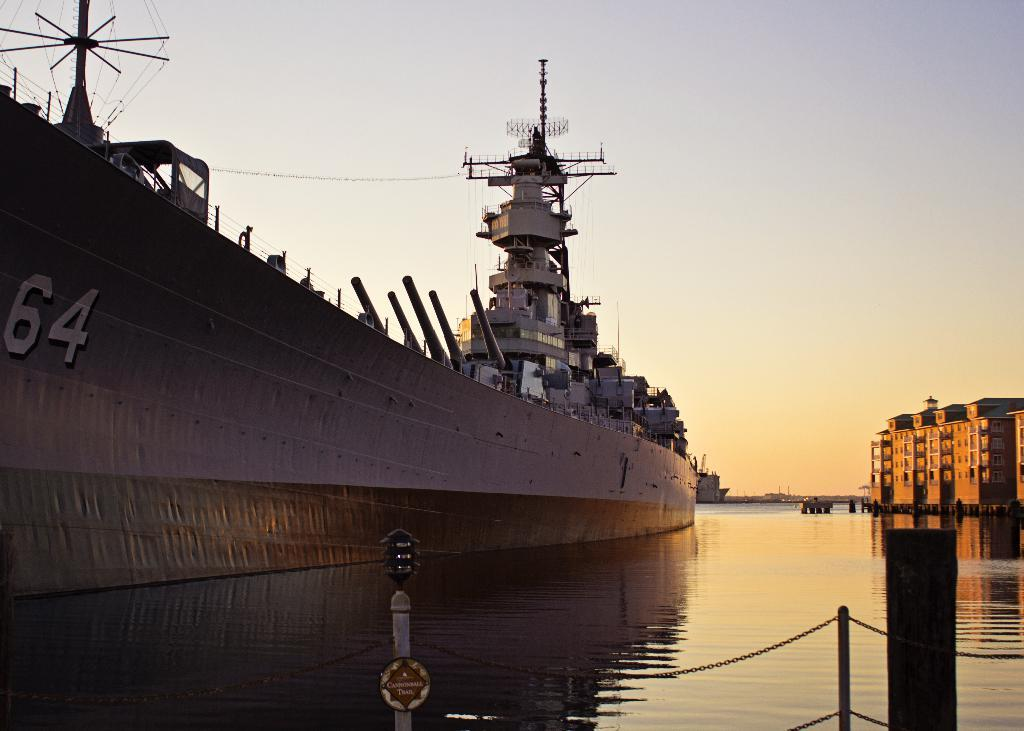What is there is a ship in the image, what is its position in relation to the water? The ship is above the water in the image. What other objects can be seen at the bottom of the image? There are poles, a chain, a light, and a board at the bottom of the image. What is visible on the right side of the image? There are buildings on the right side of the image. What can be seen in the background of the image? The sky is visible in the background of the image. What is the ship's tendency to hope for a better mind in the image? The image does not provide information about the ship's mind or its hopes; it only shows the ship's position above the water and the objects at the bottom of the image. 